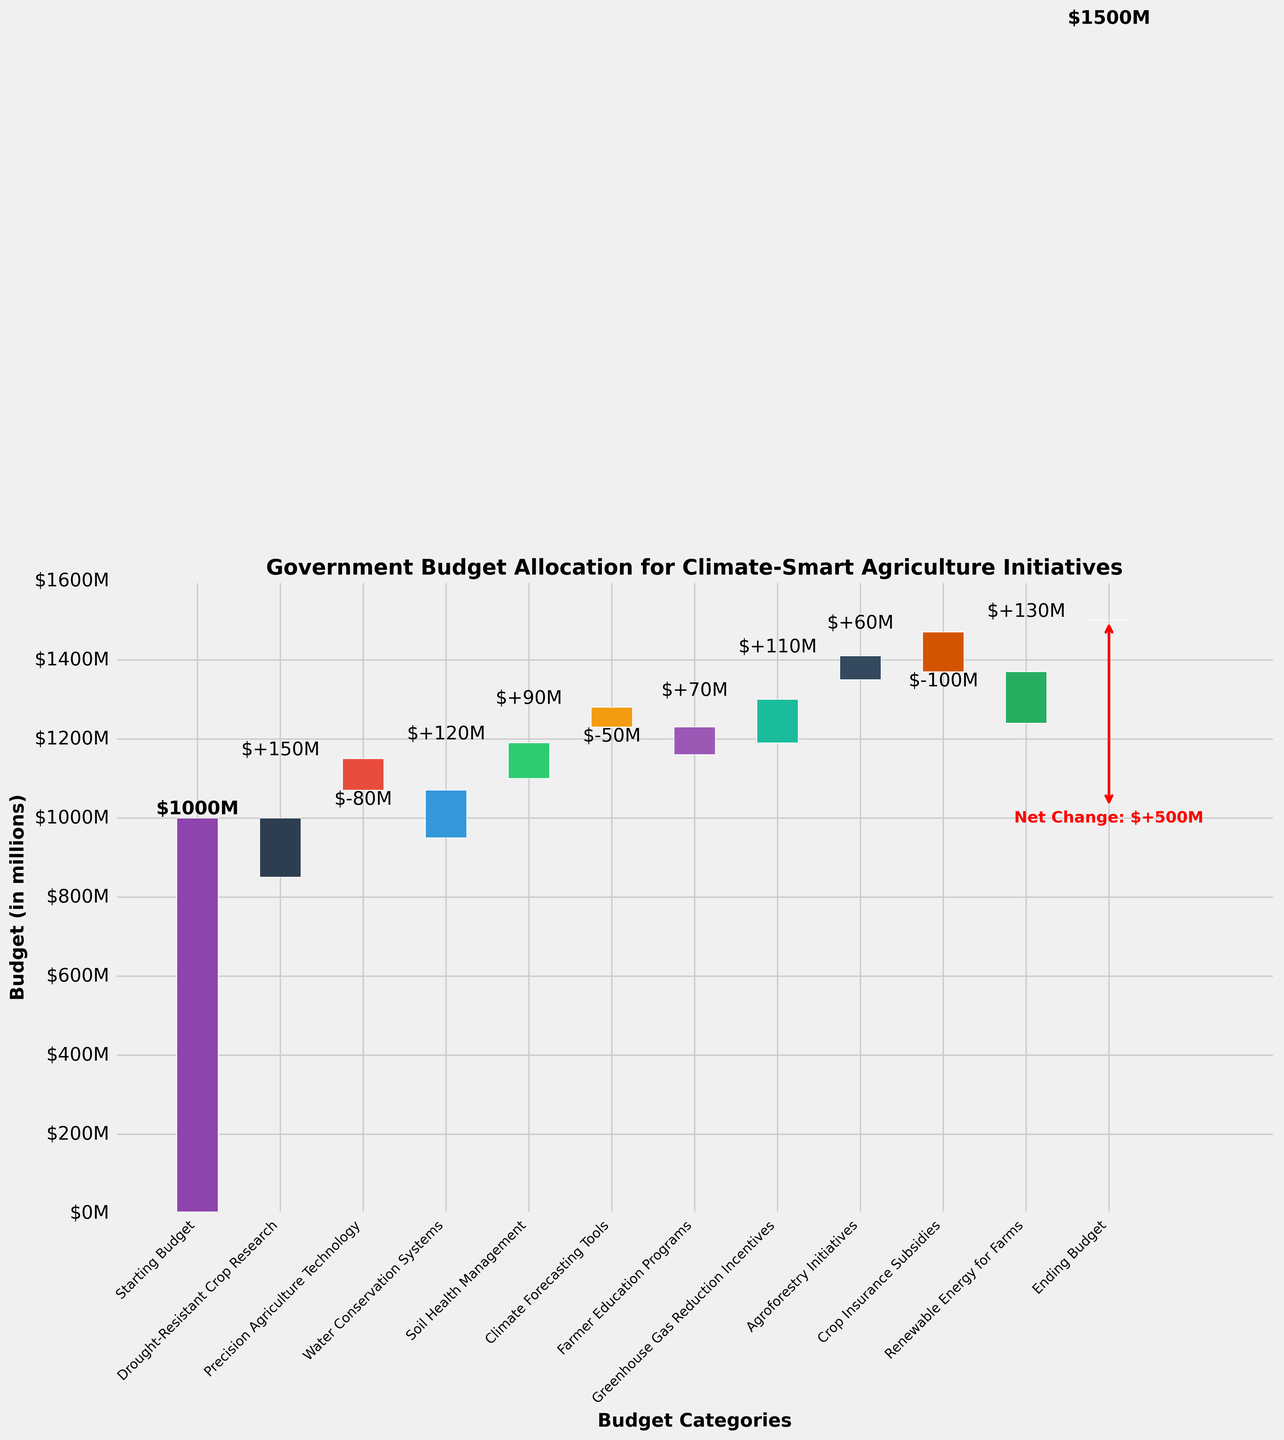What is the total starting budget for climate-smart agriculture initiatives? The total starting budget is given in the first bar of the waterfall chart. This represents the initial amount before any allocations to specific categories.
Answer: $1 billion Which category received the highest allocation of funds? By looking at the heights of the positive bars, the category with the highest allocation of funds is 'Renewable Energy for Farms', as its bar is the tallest among the positive values.
Answer: Renewable Energy for Farms Which category had the most significant reduction in budget? Among the categories with negative bars, 'Crop Insurance Subsidies' has the tallest bar downwards, indicating the most significant reduction in budget.
Answer: Crop Insurance Subsidies What is the ending budget after all allocations and reductions? The ending budget is indicated by the last bar of the waterfall chart, representing the final amount after all additions and subtractions.
Answer: $1.5 billion What's the net change in the budget from the start to the end? The net change is the difference between the ending budget and the starting budget. From the chart, the starting budget is $1 billion, and the ending budget is $1.5 billion, giving a net change of $0.5 billion.
Answer: $0.5 billion How does the allocation for 'Precision Agriculture Technology' compare to 'Soil Health Management'? Comparing the bars, 'Precision Agriculture Technology' has a negative allocation, whereas 'Soil Health Management' has a positive allocation of $90 million.
Answer: Soil Health Management received more What is the combined budget allocation for 'Drought-Resistant Crop Research' and 'Water Conservation Systems'? The values for the two categories need to be summed up. 'Drought-Resistant Crop Research' has an allocation of $150 million and 'Water Conservation Systems' $120 million. The combined allocation is $150 million + $120 million.
Answer: $270 million How many categories received a positive allocation of funds? Count the number of positive bars in the waterfall chart. These include 'Drought-Resistant Crop Research', 'Water Conservation Systems', 'Soil Health Management', 'Farmer Education Programs', 'Greenhouse Gas Reduction Incentives', 'Agroforestry Initiatives', and 'Renewable Energy for Farms'.
Answer: 7 categories Which category had a budget reduction but less than $100 million? 'Precision Agriculture Technology' and 'Climate Forecasting Tools' have budget reductions, but their values are less than $100 million.
Answer: Precision Agriculture Technology and Climate Forecasting Tools What is the impact of 'Farmer Education Programs' on the budget? Locate the bar representing 'Farmer Education Programs'. The chart shows this category has a positive impact with an allocation of $70 million.
Answer: Positive impact of $70 million 